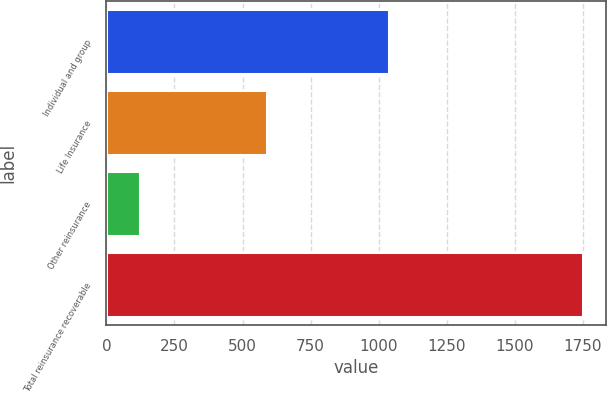Convert chart. <chart><loc_0><loc_0><loc_500><loc_500><bar_chart><fcel>Individual and group<fcel>Life Insurance<fcel>Other reinsurance<fcel>Total reinsurance recoverable<nl><fcel>1038<fcel>589<fcel>122<fcel>1749<nl></chart> 